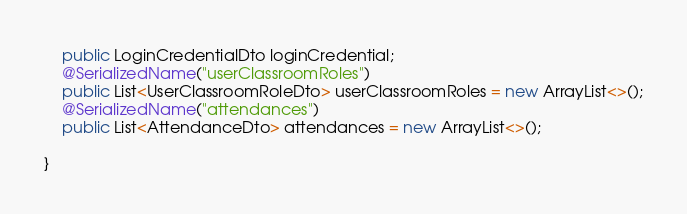<code> <loc_0><loc_0><loc_500><loc_500><_Java_>    public LoginCredentialDto loginCredential;
    @SerializedName("userClassroomRoles")
    public List<UserClassroomRoleDto> userClassroomRoles = new ArrayList<>();
    @SerializedName("attendances")
    public List<AttendanceDto> attendances = new ArrayList<>();

}
</code> 